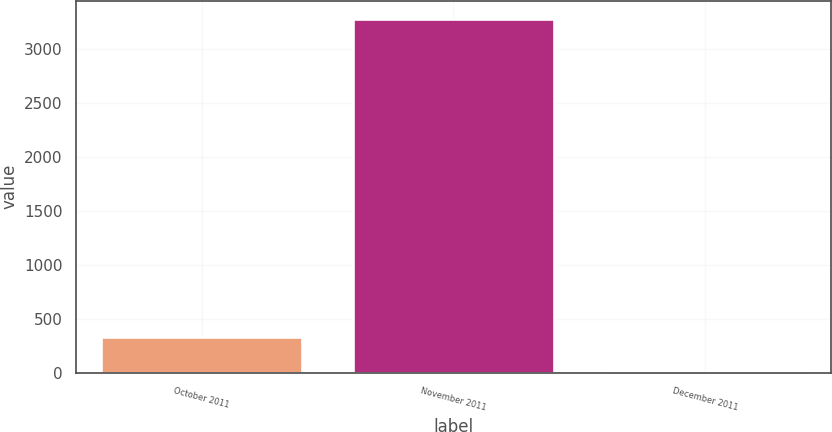Convert chart. <chart><loc_0><loc_0><loc_500><loc_500><bar_chart><fcel>October 2011<fcel>November 2011<fcel>December 2011<nl><fcel>331.31<fcel>3279<fcel>3.79<nl></chart> 